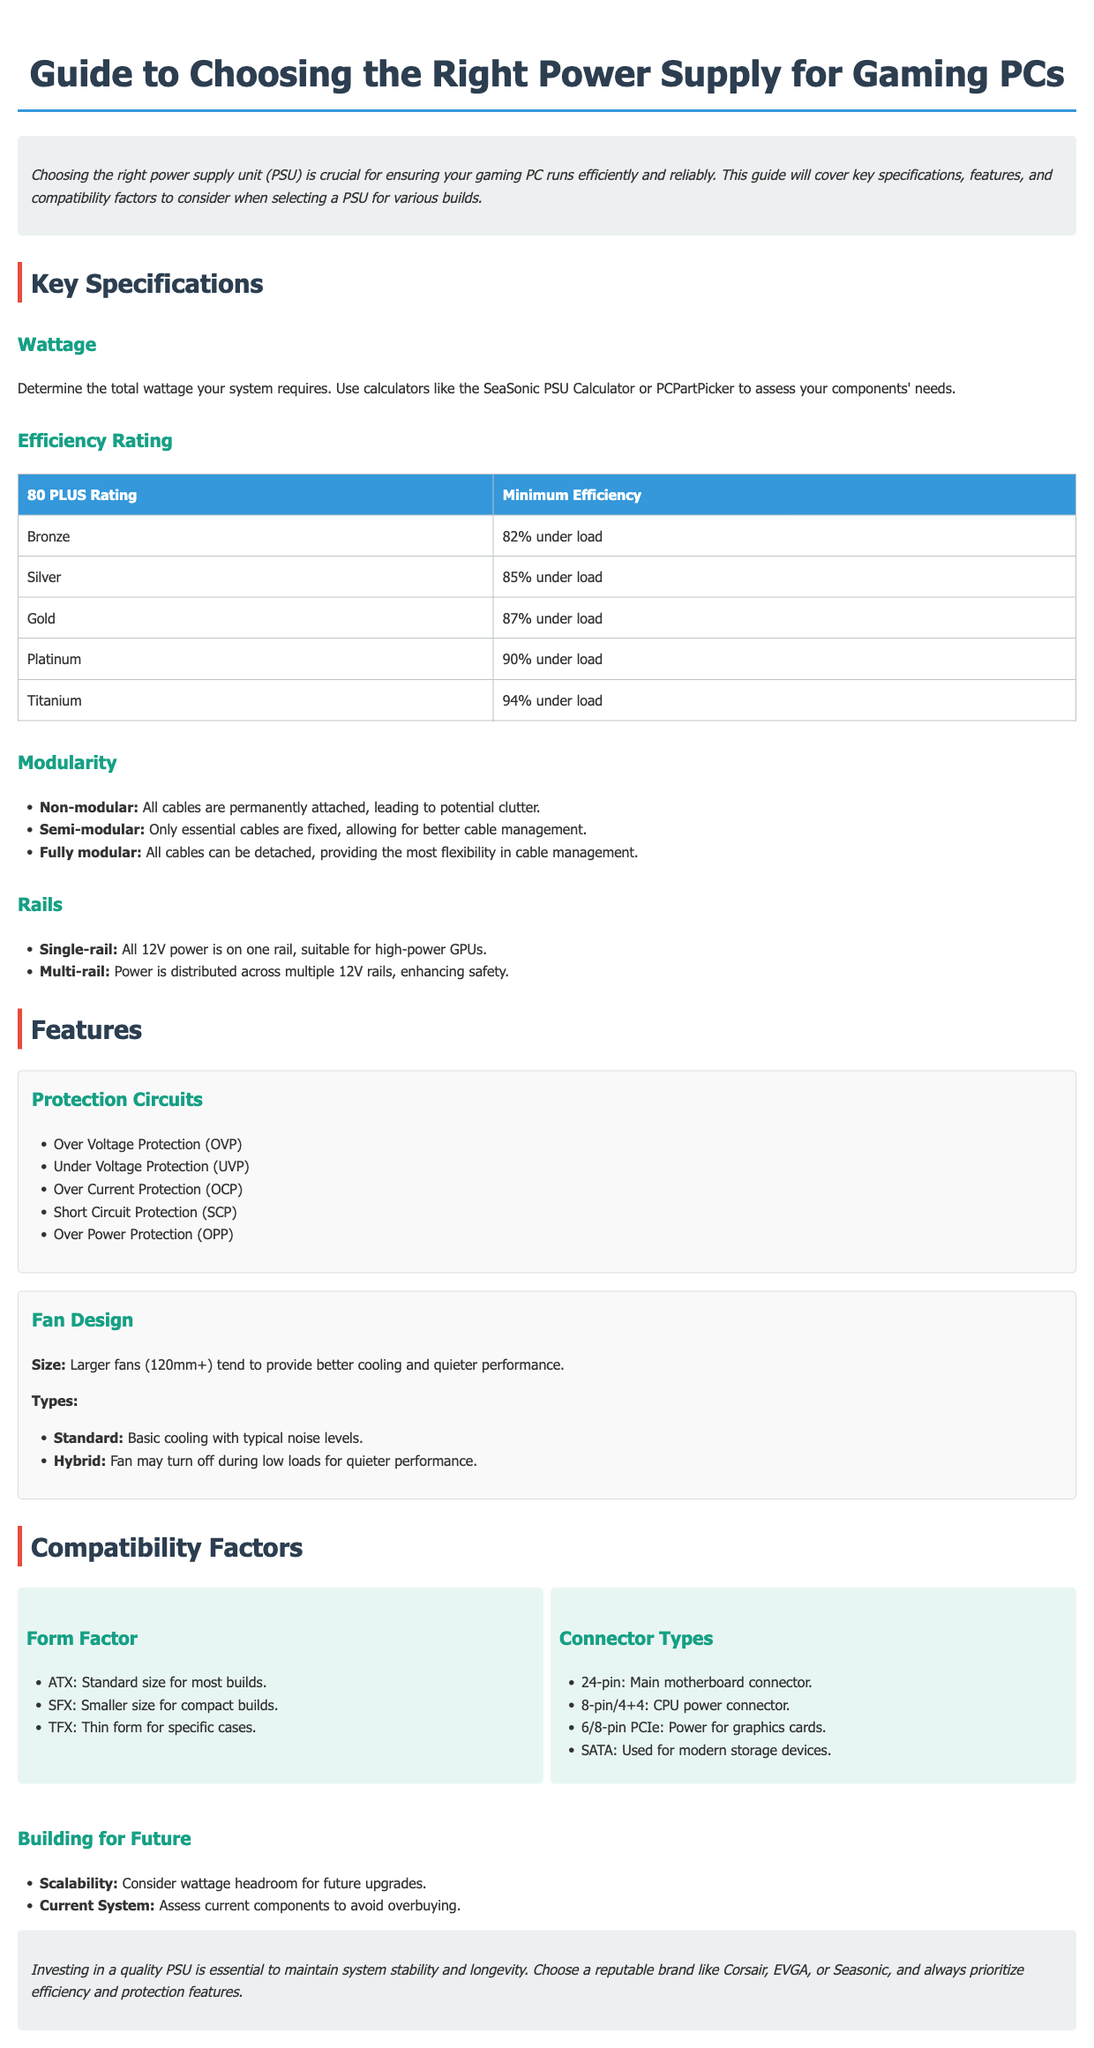What is the recommended minimum efficiency for a Silver PSU? The minimum efficiency for a Silver PSU is listed in the efficiency rating table as 85% under load.
Answer: 85% What are the three types of modularity mentioned? The document specifies non-modular, semi-modular, and fully modular as the three types of modularity for PSUs.
Answer: Non-modular, Semi-modular, Fully modular What is the main motherboard connector type? The main motherboard connector type is explicitly stated in the compatibility section as 24-pin.
Answer: 24-pin What is the advantage of a multi-rail design? The document describes the advantage of a multi-rail design as enhanced safety due to the distribution of power across multiple 12V rails.
Answer: Enhanced safety Which brand is suggested as a reputable choice for PSUs? The conclusion section recommends specific brands like Corsair, EVGA, or Seasonic as reputable choices for PSUs.
Answer: Corsair, EVGA, Seasonic What is the minimum efficiency for a Titanium rated PSU? The minimum efficiency for a Titanium rated PSU is detailed in the table, showing that it is 94% under load.
Answer: 94% How does a hybrid fan design perform under low loads? The fan design type indicates that a hybrid fan may turn off during low loads for quieter performance.
Answer: Quieter performance What are the three form factors mentioned for PSUs? The document lists ATX, SFX, and TFX as the three form factors for PSUs in the compatibility section.
Answer: ATX, SFX, TFX What protection feature is abbreviated as OVP? OVP stands for Over Voltage Protection, which is one of the mentioned protection circuits in the features section.
Answer: Over Voltage Protection 